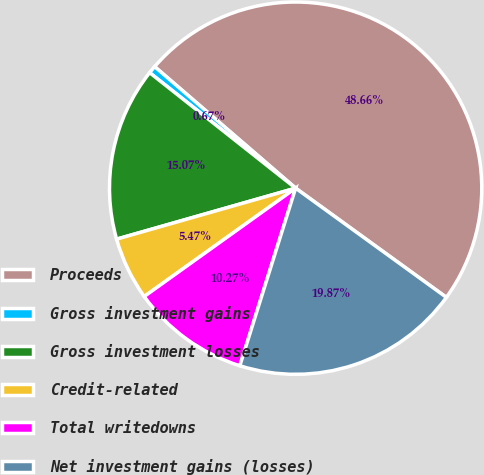Convert chart. <chart><loc_0><loc_0><loc_500><loc_500><pie_chart><fcel>Proceeds<fcel>Gross investment gains<fcel>Gross investment losses<fcel>Credit-related<fcel>Total writedowns<fcel>Net investment gains (losses)<nl><fcel>48.66%<fcel>0.67%<fcel>15.07%<fcel>5.47%<fcel>10.27%<fcel>19.87%<nl></chart> 